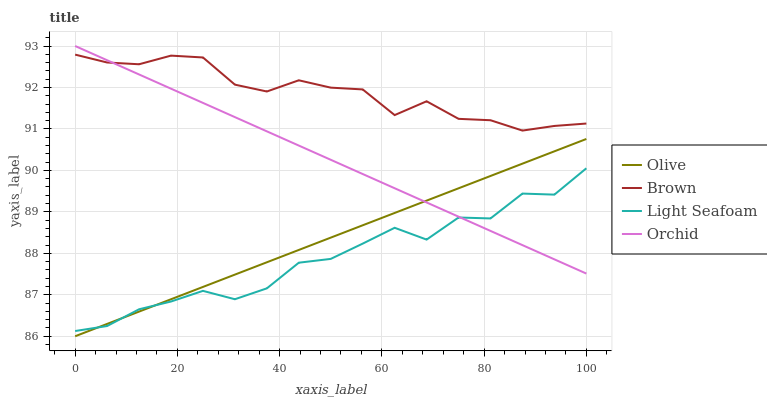Does Brown have the minimum area under the curve?
Answer yes or no. No. Does Light Seafoam have the maximum area under the curve?
Answer yes or no. No. Is Brown the smoothest?
Answer yes or no. No. Is Brown the roughest?
Answer yes or no. No. Does Light Seafoam have the lowest value?
Answer yes or no. No. Does Brown have the highest value?
Answer yes or no. No. Is Olive less than Brown?
Answer yes or no. Yes. Is Brown greater than Olive?
Answer yes or no. Yes. Does Olive intersect Brown?
Answer yes or no. No. 